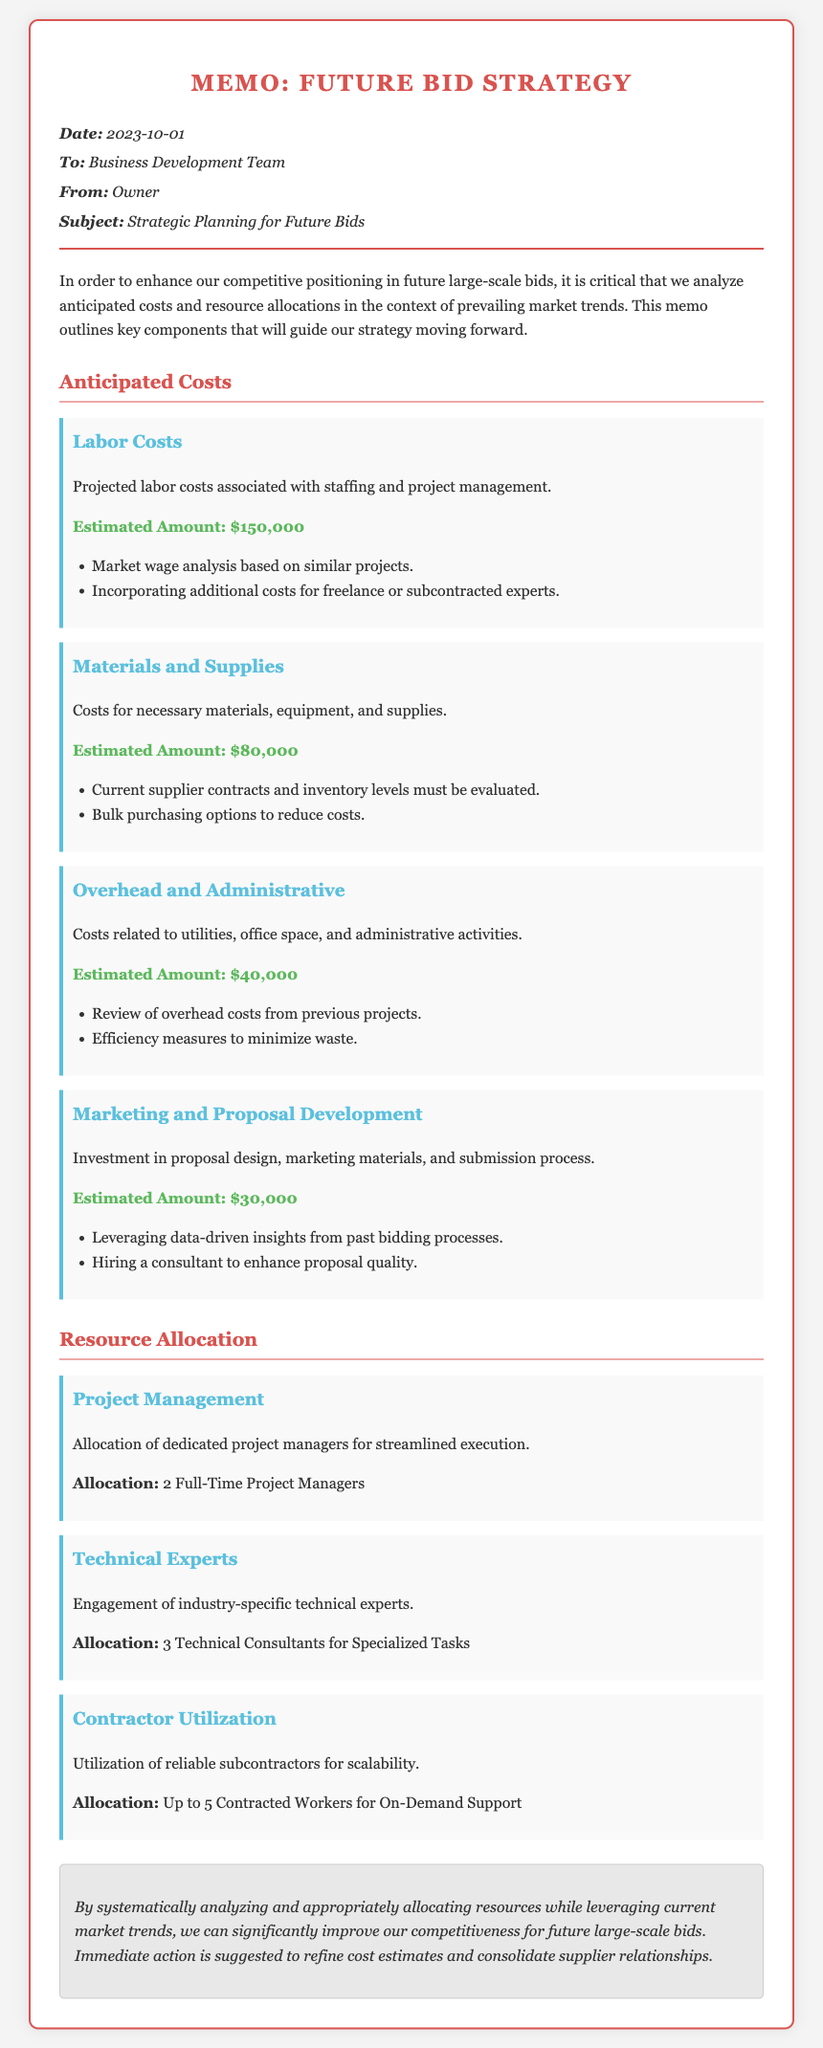What is the date of the memo? The date of the memo can be found in the header section, which states "Date: 2023-10-01."
Answer: 2023-10-01 What are the anticipated labor costs? The section on anticipated costs provides an estimated amount for labor costs, which is "$150,000."
Answer: $150,000 How many technical consultants are allocated? The resource allocation section indicates the allocation as "3 Technical Consultants for Specialized Tasks."
Answer: 3 Technical Consultants What is the estimated amount for marketing and proposal development? The marketing and proposal development cost item specifies the estimated amount as "$30,000."
Answer: $30,000 What is the total estimated amount for materials and supplies? The cost section lists the estimated amount for materials and supplies, which is "$80,000."
Answer: $80,000 How many project managers are allocated? The resource allocation details state "2 Full-Time Project Managers."
Answer: 2 Full-Time Project Managers What is suggested for immediate action? The conclusion emphasizes that "immediate action is suggested to refine cost estimates and consolidate supplier relationships."
Answer: Immediate action is suggested to refine cost estimates and consolidate supplier relationships What type of document is this? The document is identified as a "Memo," specifically for "Strategic Planning for Future Bids."
Answer: Memo 